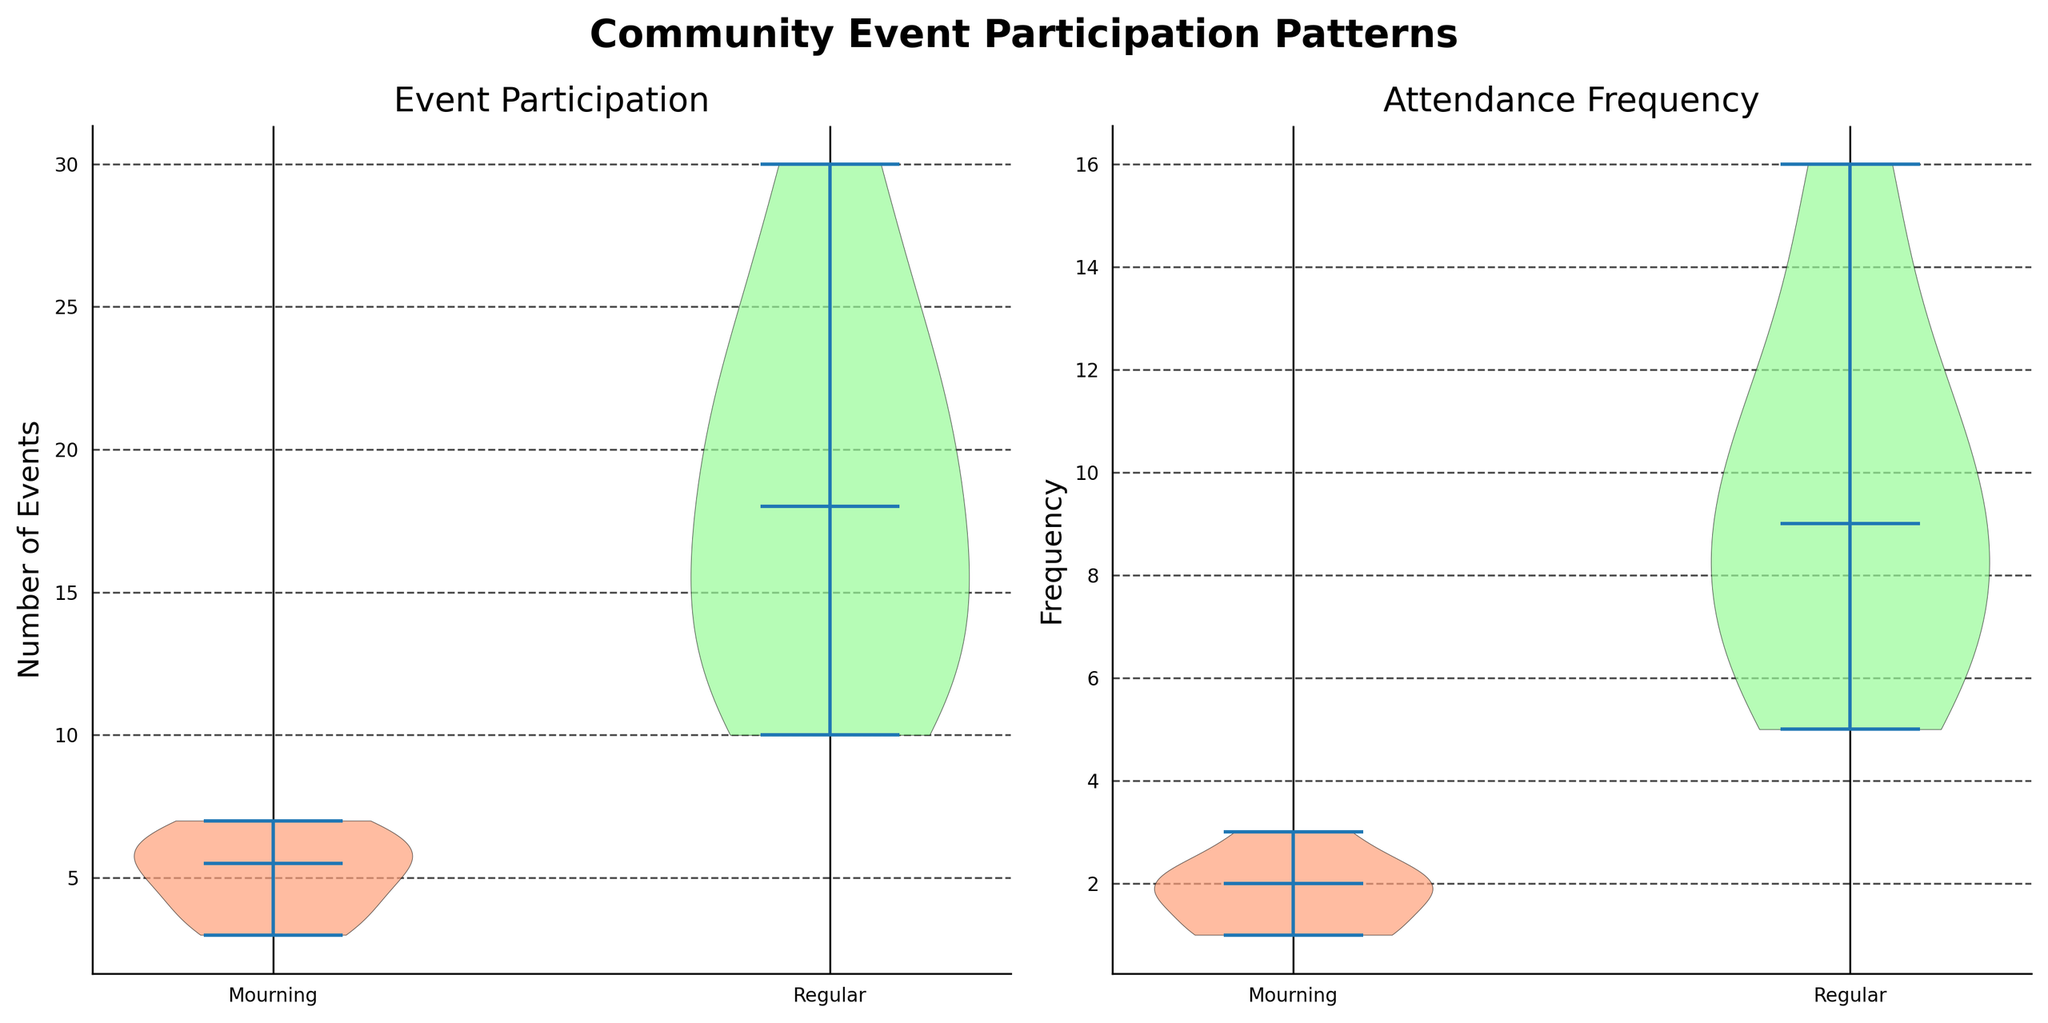What's the title of the figure? The title of the figure is written at the top in bold and large font. It reads "Community Event Participation Patterns".
Answer: Community Event Participation Patterns What are the x-axis labels for the first subplot? The first subplot represents event participation, with x-axis labels "Mourning" for the left violin plot and "Regular" for the right.
Answer: Mourning, Regular Which group shows a higher range of event participation? The range is visually wider in the violin plot for the "Regular" group compared to the "Mourning" group.
Answer: Regular Which violin plot has a higher median for attendance frequency? The median is represented by a horizontal line inside the violin plots, and the "Regular" group shows a higher median line than the "Mourning" group.
Answer: Regular How does the mean of attendance frequency compare between the groups? The mean is suggested by the depth of the body of the violin plot. The "Regular" group appears to cluster around a higher frequency than the "Mourning" group.
Answer: Regular is greater Which subplot's y-axis deals with frequency? The second subplot, titled "Attendance Frequency", has a y-axis labeled "Frequency".
Answer: Attendance Frequency Compare the general spread of the data in the Event Participation subplot. Which group is more spread out? The shape of the violin plot for the "Regular" group shows a wider spread compared to the "Mourning" group, indicating more variability in event participation.
Answer: Regular Estimate the median for Event Participation in the "Mourning" group. The median for the "Mourning" group's event participation is represented by the horizontal line in the first violin plot, which is at approximately 5.
Answer: Approximately 5 Compare the level of engagement for families with and without recent bereavements. Which group tends to have higher engagement based on the subplots? The violin plots for both Event Participation and Attendance Frequency show that the "Regular" group has higher values and variability, indicating higher engagement compared to the "Mourning" group.
Answer: Regular 